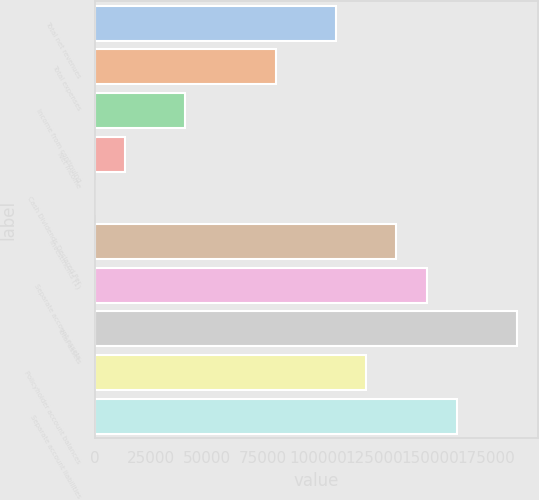Convert chart. <chart><loc_0><loc_0><loc_500><loc_500><bar_chart><fcel>Total net revenues<fcel>Total expenses<fcel>Income from continuing<fcel>Net income<fcel>Cash Dividends Declared Per<fcel>Investments (1)<fcel>Separate account assets<fcel>Total assets<fcel>Policyholder account balances<fcel>Separate account liabilities<nl><fcel>107783<fcel>80837.9<fcel>40419.5<fcel>13473.9<fcel>1.15<fcel>134729<fcel>148202<fcel>188620<fcel>121256<fcel>161675<nl></chart> 